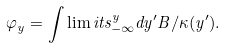<formula> <loc_0><loc_0><loc_500><loc_500>\varphi _ { y } = \int \lim i t s _ { - \infty } ^ { y } d y ^ { \prime } B / \kappa ( y ^ { \prime } ) .</formula> 